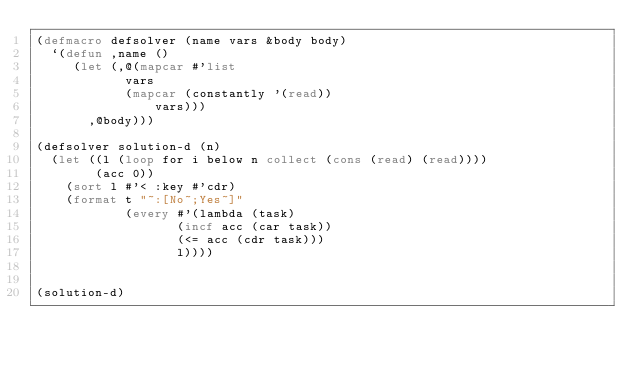<code> <loc_0><loc_0><loc_500><loc_500><_Lisp_>(defmacro defsolver (name vars &body body)
  `(defun ,name ()
     (let (,@(mapcar #'list
            vars
            (mapcar (constantly '(read))
                vars)))
       ,@body)))

(defsolver solution-d (n)
  (let ((l (loop for i below n collect (cons (read) (read))))
        (acc 0))
    (sort l #'< :key #'cdr)
    (format t "~:[No~;Yes~]"
            (every #'(lambda (task)
                   (incf acc (car task))
                   (<= acc (cdr task)))
                   l))))


(solution-d)

</code> 